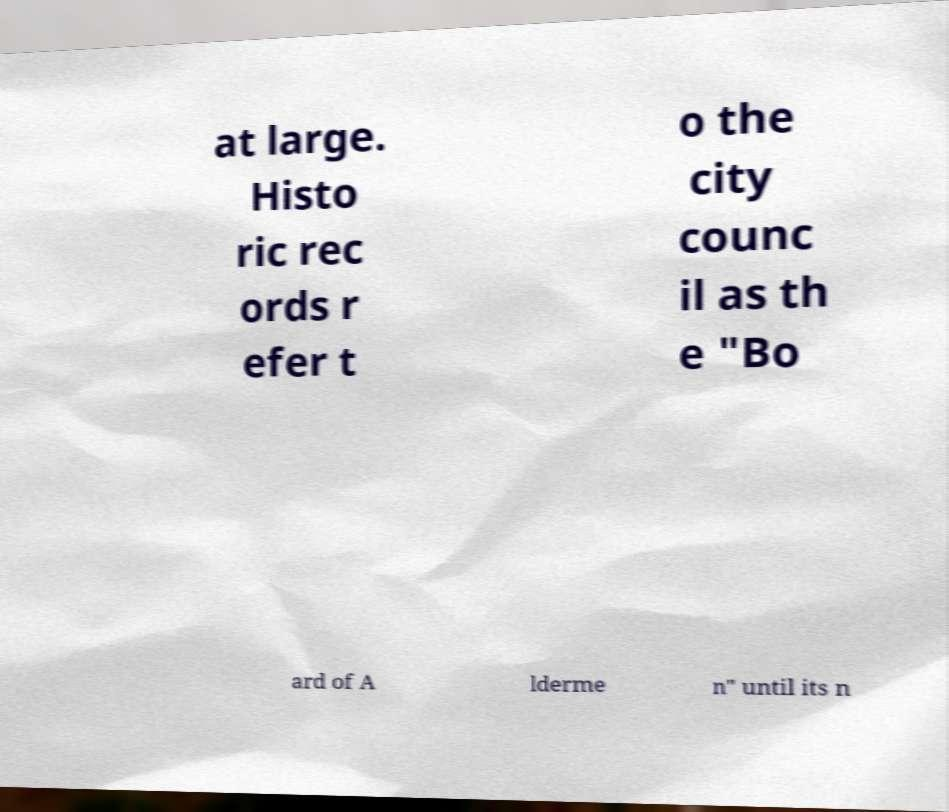Could you extract and type out the text from this image? at large. Histo ric rec ords r efer t o the city counc il as th e "Bo ard of A lderme n" until its n 